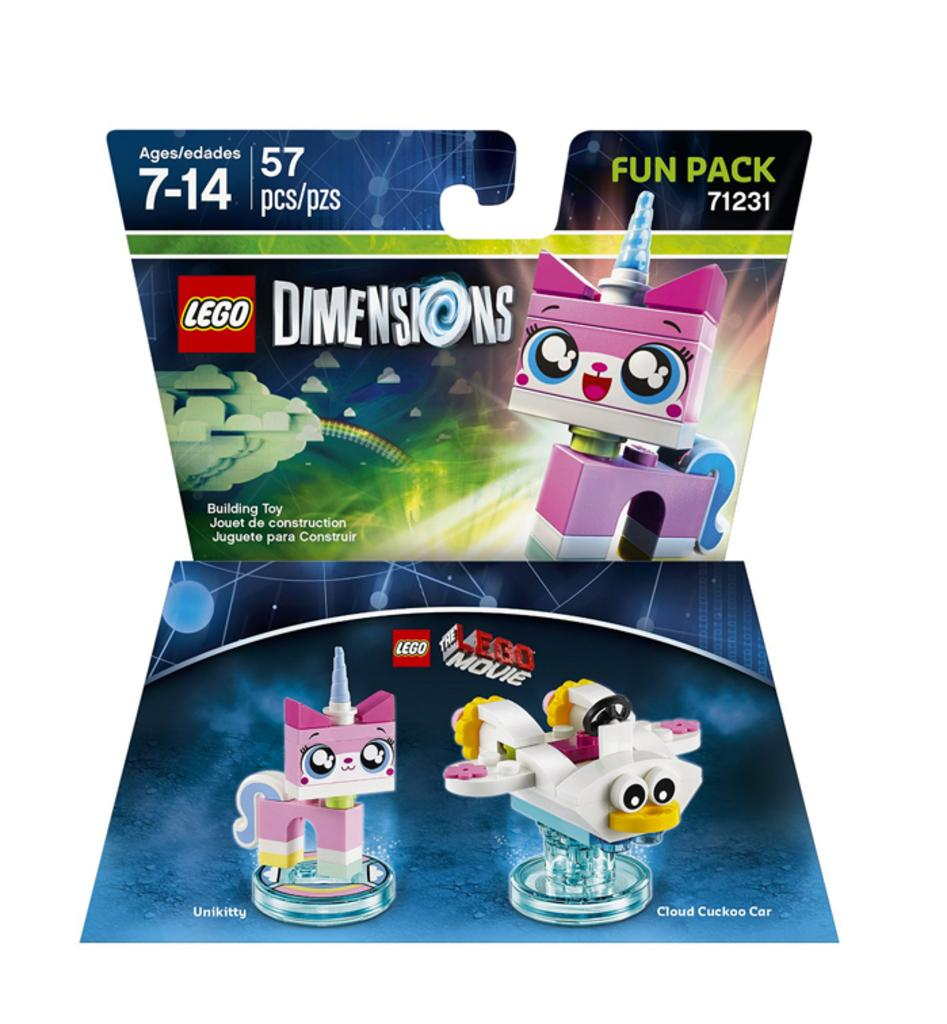What is the main subject of the image? The image appears to be a poster and a board. What type of images can be seen on the poster? There are pictures of toys on the poster. What other elements are present on the poster besides the images? There are letters and numbers on the poster. What is the color of the background on the poster? The background of the poster is white in color. Can you tell me how many balls are present in the image? There are no balls present in the image; it features pictures of toys, letters, and numbers on a white background. Is there a crib visible in the image? There is no crib present in the image; it is a poster with pictures of toys, letters, and numbers on a white background. 